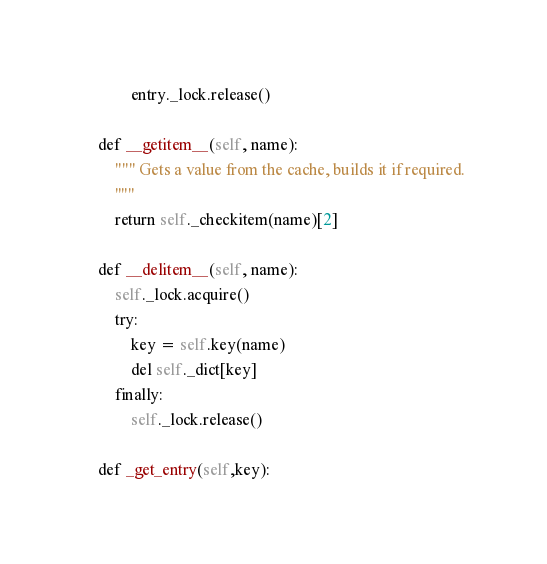Convert code to text. <code><loc_0><loc_0><loc_500><loc_500><_Python_>            entry._lock.release()

    def __getitem__(self, name):
        """ Gets a value from the cache, builds it if required.
        """
        return self._checkitem(name)[2]

    def __delitem__(self, name):
        self._lock.acquire()
        try:
            key = self.key(name)
            del self._dict[key]
        finally:
            self._lock.release()

    def _get_entry(self,key):</code> 